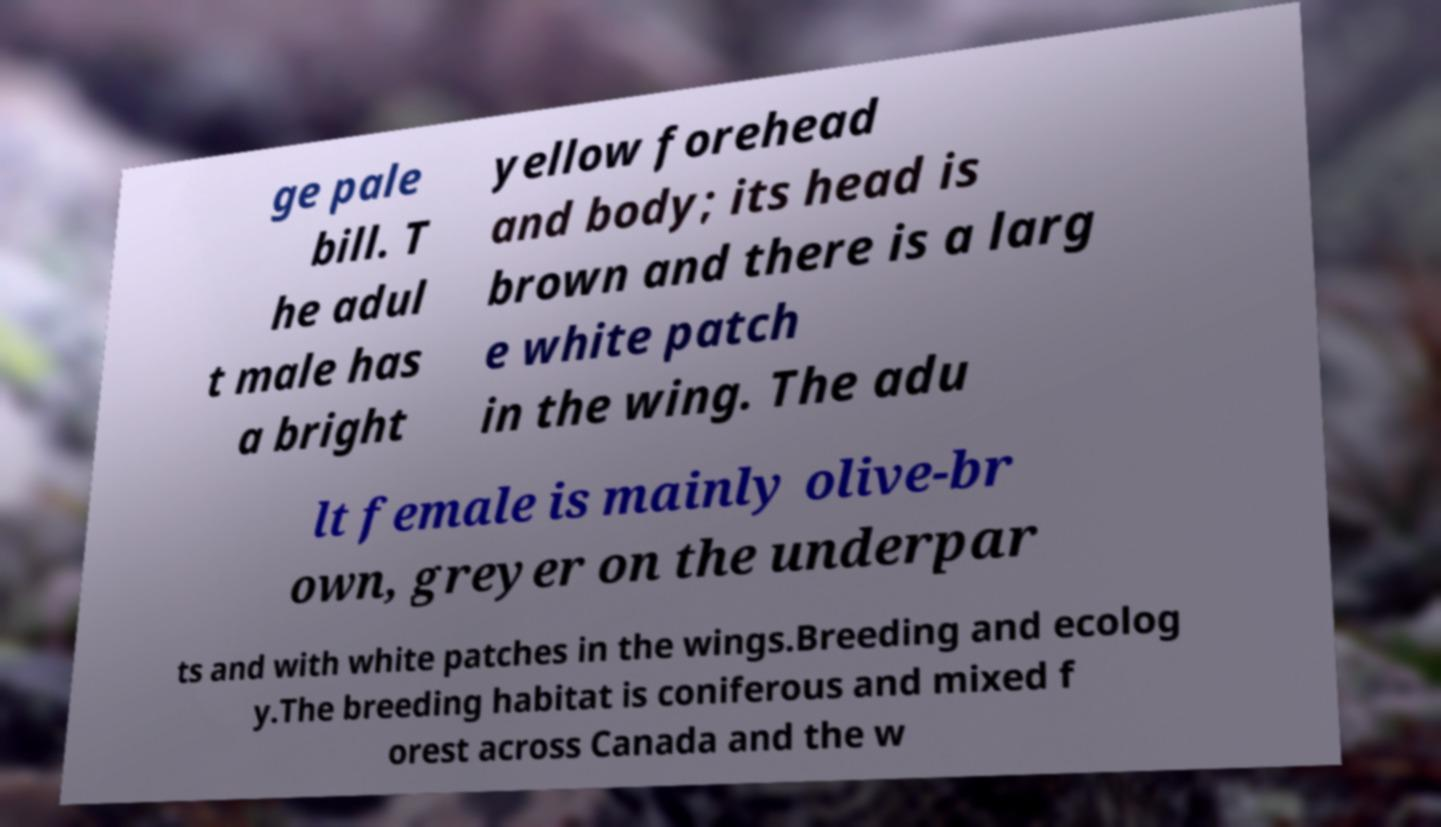For documentation purposes, I need the text within this image transcribed. Could you provide that? ge pale bill. T he adul t male has a bright yellow forehead and body; its head is brown and there is a larg e white patch in the wing. The adu lt female is mainly olive-br own, greyer on the underpar ts and with white patches in the wings.Breeding and ecolog y.The breeding habitat is coniferous and mixed f orest across Canada and the w 